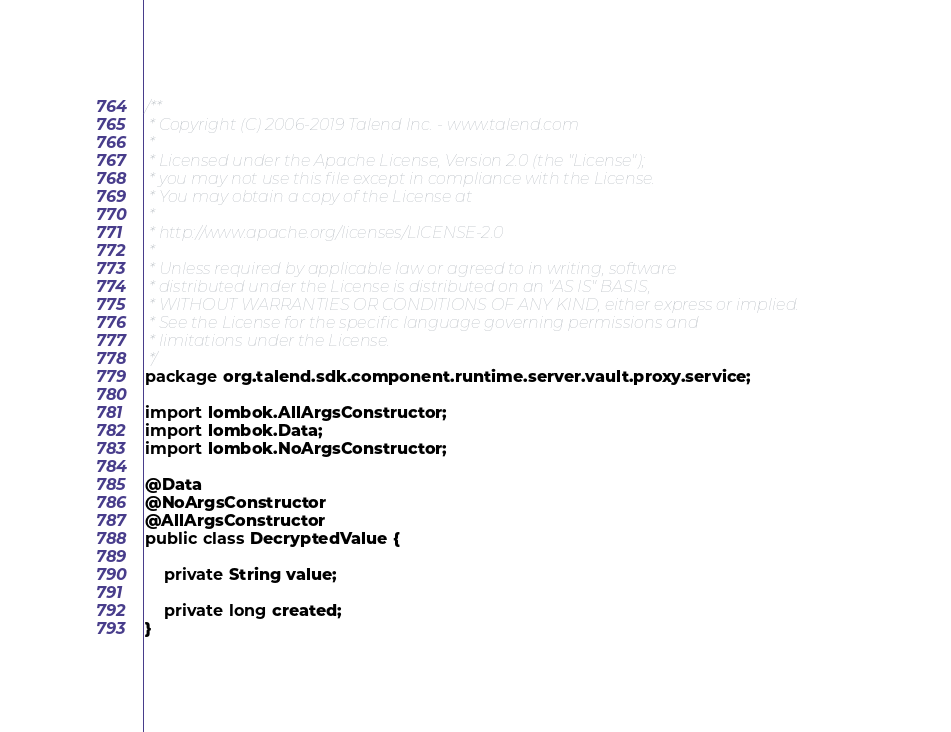Convert code to text. <code><loc_0><loc_0><loc_500><loc_500><_Java_>/**
 * Copyright (C) 2006-2019 Talend Inc. - www.talend.com
 *
 * Licensed under the Apache License, Version 2.0 (the "License");
 * you may not use this file except in compliance with the License.
 * You may obtain a copy of the License at
 *
 * http://www.apache.org/licenses/LICENSE-2.0
 *
 * Unless required by applicable law or agreed to in writing, software
 * distributed under the License is distributed on an "AS IS" BASIS,
 * WITHOUT WARRANTIES OR CONDITIONS OF ANY KIND, either express or implied.
 * See the License for the specific language governing permissions and
 * limitations under the License.
 */
package org.talend.sdk.component.runtime.server.vault.proxy.service;

import lombok.AllArgsConstructor;
import lombok.Data;
import lombok.NoArgsConstructor;

@Data
@NoArgsConstructor
@AllArgsConstructor
public class DecryptedValue {

    private String value;

    private long created;
}
</code> 